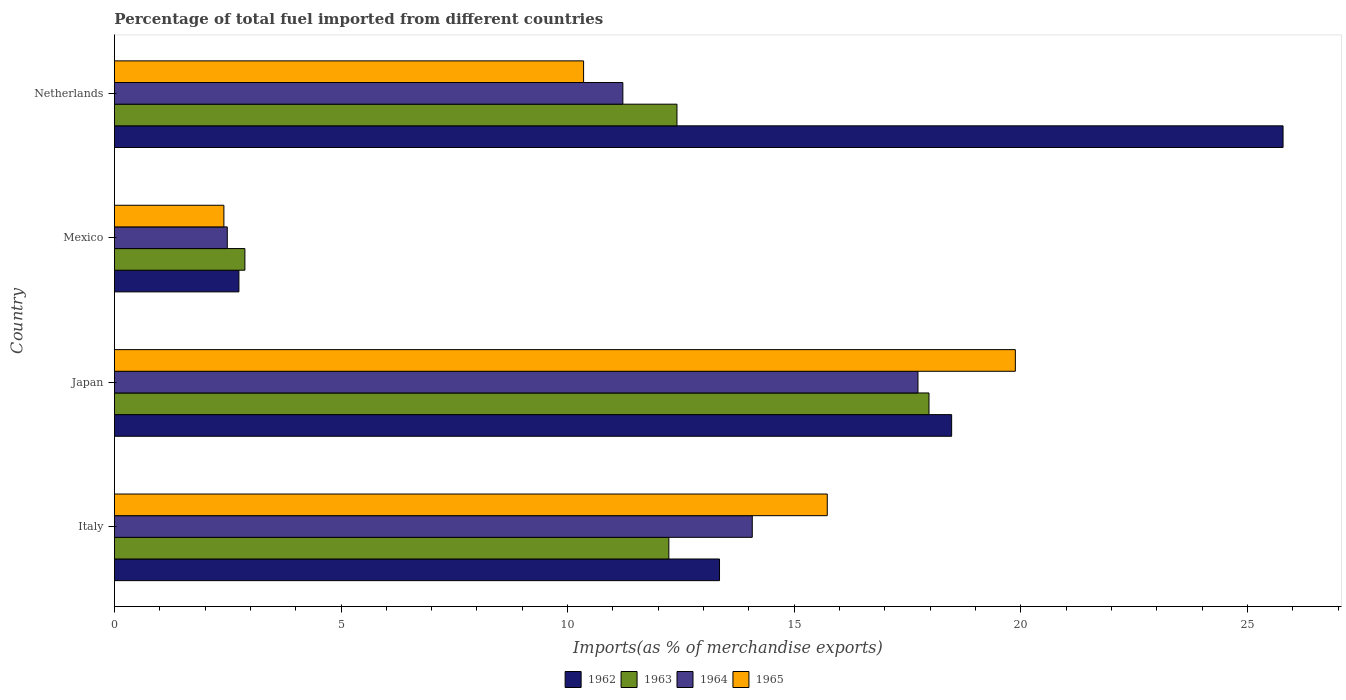How many different coloured bars are there?
Offer a terse response. 4. Are the number of bars on each tick of the Y-axis equal?
Offer a very short reply. Yes. What is the percentage of imports to different countries in 1964 in Japan?
Ensure brevity in your answer.  17.73. Across all countries, what is the maximum percentage of imports to different countries in 1962?
Offer a terse response. 25.79. Across all countries, what is the minimum percentage of imports to different countries in 1964?
Your answer should be very brief. 2.49. What is the total percentage of imports to different countries in 1964 in the graph?
Make the answer very short. 45.52. What is the difference between the percentage of imports to different countries in 1963 in Italy and that in Japan?
Your response must be concise. -5.74. What is the difference between the percentage of imports to different countries in 1964 in Mexico and the percentage of imports to different countries in 1963 in Netherlands?
Give a very brief answer. -9.92. What is the average percentage of imports to different countries in 1962 per country?
Your answer should be compact. 15.09. What is the difference between the percentage of imports to different countries in 1963 and percentage of imports to different countries in 1964 in Italy?
Offer a terse response. -1.84. What is the ratio of the percentage of imports to different countries in 1963 in Italy to that in Japan?
Give a very brief answer. 0.68. What is the difference between the highest and the second highest percentage of imports to different countries in 1963?
Give a very brief answer. 5.56. What is the difference between the highest and the lowest percentage of imports to different countries in 1962?
Make the answer very short. 23.04. Is the sum of the percentage of imports to different countries in 1962 in Japan and Mexico greater than the maximum percentage of imports to different countries in 1965 across all countries?
Ensure brevity in your answer.  Yes. Is it the case that in every country, the sum of the percentage of imports to different countries in 1963 and percentage of imports to different countries in 1964 is greater than the sum of percentage of imports to different countries in 1965 and percentage of imports to different countries in 1962?
Your answer should be compact. No. What does the 3rd bar from the top in Netherlands represents?
Your answer should be compact. 1963. What does the 4th bar from the bottom in Japan represents?
Keep it short and to the point. 1965. How many bars are there?
Keep it short and to the point. 16. Are all the bars in the graph horizontal?
Ensure brevity in your answer.  Yes. How many countries are there in the graph?
Offer a terse response. 4. Are the values on the major ticks of X-axis written in scientific E-notation?
Keep it short and to the point. No. What is the title of the graph?
Offer a terse response. Percentage of total fuel imported from different countries. Does "1967" appear as one of the legend labels in the graph?
Offer a terse response. No. What is the label or title of the X-axis?
Provide a succinct answer. Imports(as % of merchandise exports). What is the label or title of the Y-axis?
Give a very brief answer. Country. What is the Imports(as % of merchandise exports) in 1962 in Italy?
Provide a short and direct response. 13.35. What is the Imports(as % of merchandise exports) of 1963 in Italy?
Your answer should be very brief. 12.23. What is the Imports(as % of merchandise exports) of 1964 in Italy?
Make the answer very short. 14.07. What is the Imports(as % of merchandise exports) of 1965 in Italy?
Give a very brief answer. 15.73. What is the Imports(as % of merchandise exports) of 1962 in Japan?
Your response must be concise. 18.47. What is the Imports(as % of merchandise exports) in 1963 in Japan?
Keep it short and to the point. 17.97. What is the Imports(as % of merchandise exports) in 1964 in Japan?
Provide a short and direct response. 17.73. What is the Imports(as % of merchandise exports) in 1965 in Japan?
Ensure brevity in your answer.  19.88. What is the Imports(as % of merchandise exports) of 1962 in Mexico?
Provide a succinct answer. 2.75. What is the Imports(as % of merchandise exports) in 1963 in Mexico?
Your response must be concise. 2.88. What is the Imports(as % of merchandise exports) in 1964 in Mexico?
Your answer should be compact. 2.49. What is the Imports(as % of merchandise exports) of 1965 in Mexico?
Make the answer very short. 2.42. What is the Imports(as % of merchandise exports) in 1962 in Netherlands?
Ensure brevity in your answer.  25.79. What is the Imports(as % of merchandise exports) of 1963 in Netherlands?
Provide a succinct answer. 12.41. What is the Imports(as % of merchandise exports) of 1964 in Netherlands?
Keep it short and to the point. 11.22. What is the Imports(as % of merchandise exports) of 1965 in Netherlands?
Your answer should be very brief. 10.35. Across all countries, what is the maximum Imports(as % of merchandise exports) in 1962?
Offer a terse response. 25.79. Across all countries, what is the maximum Imports(as % of merchandise exports) in 1963?
Offer a very short reply. 17.97. Across all countries, what is the maximum Imports(as % of merchandise exports) of 1964?
Make the answer very short. 17.73. Across all countries, what is the maximum Imports(as % of merchandise exports) in 1965?
Your answer should be very brief. 19.88. Across all countries, what is the minimum Imports(as % of merchandise exports) of 1962?
Offer a very short reply. 2.75. Across all countries, what is the minimum Imports(as % of merchandise exports) of 1963?
Keep it short and to the point. 2.88. Across all countries, what is the minimum Imports(as % of merchandise exports) of 1964?
Provide a short and direct response. 2.49. Across all countries, what is the minimum Imports(as % of merchandise exports) in 1965?
Your answer should be very brief. 2.42. What is the total Imports(as % of merchandise exports) in 1962 in the graph?
Give a very brief answer. 60.36. What is the total Imports(as % of merchandise exports) of 1963 in the graph?
Offer a terse response. 45.5. What is the total Imports(as % of merchandise exports) in 1964 in the graph?
Provide a short and direct response. 45.52. What is the total Imports(as % of merchandise exports) of 1965 in the graph?
Your answer should be very brief. 48.38. What is the difference between the Imports(as % of merchandise exports) of 1962 in Italy and that in Japan?
Make the answer very short. -5.12. What is the difference between the Imports(as % of merchandise exports) in 1963 in Italy and that in Japan?
Your answer should be very brief. -5.74. What is the difference between the Imports(as % of merchandise exports) in 1964 in Italy and that in Japan?
Make the answer very short. -3.66. What is the difference between the Imports(as % of merchandise exports) of 1965 in Italy and that in Japan?
Ensure brevity in your answer.  -4.15. What is the difference between the Imports(as % of merchandise exports) in 1962 in Italy and that in Mexico?
Your response must be concise. 10.61. What is the difference between the Imports(as % of merchandise exports) in 1963 in Italy and that in Mexico?
Make the answer very short. 9.36. What is the difference between the Imports(as % of merchandise exports) in 1964 in Italy and that in Mexico?
Make the answer very short. 11.58. What is the difference between the Imports(as % of merchandise exports) in 1965 in Italy and that in Mexico?
Make the answer very short. 13.31. What is the difference between the Imports(as % of merchandise exports) of 1962 in Italy and that in Netherlands?
Offer a terse response. -12.44. What is the difference between the Imports(as % of merchandise exports) in 1963 in Italy and that in Netherlands?
Offer a very short reply. -0.18. What is the difference between the Imports(as % of merchandise exports) in 1964 in Italy and that in Netherlands?
Make the answer very short. 2.86. What is the difference between the Imports(as % of merchandise exports) in 1965 in Italy and that in Netherlands?
Your answer should be very brief. 5.38. What is the difference between the Imports(as % of merchandise exports) of 1962 in Japan and that in Mexico?
Ensure brevity in your answer.  15.73. What is the difference between the Imports(as % of merchandise exports) of 1963 in Japan and that in Mexico?
Provide a succinct answer. 15.1. What is the difference between the Imports(as % of merchandise exports) in 1964 in Japan and that in Mexico?
Ensure brevity in your answer.  15.24. What is the difference between the Imports(as % of merchandise exports) in 1965 in Japan and that in Mexico?
Ensure brevity in your answer.  17.46. What is the difference between the Imports(as % of merchandise exports) of 1962 in Japan and that in Netherlands?
Provide a short and direct response. -7.31. What is the difference between the Imports(as % of merchandise exports) of 1963 in Japan and that in Netherlands?
Provide a succinct answer. 5.56. What is the difference between the Imports(as % of merchandise exports) of 1964 in Japan and that in Netherlands?
Provide a succinct answer. 6.51. What is the difference between the Imports(as % of merchandise exports) in 1965 in Japan and that in Netherlands?
Offer a very short reply. 9.53. What is the difference between the Imports(as % of merchandise exports) of 1962 in Mexico and that in Netherlands?
Your response must be concise. -23.04. What is the difference between the Imports(as % of merchandise exports) in 1963 in Mexico and that in Netherlands?
Provide a short and direct response. -9.53. What is the difference between the Imports(as % of merchandise exports) in 1964 in Mexico and that in Netherlands?
Make the answer very short. -8.73. What is the difference between the Imports(as % of merchandise exports) of 1965 in Mexico and that in Netherlands?
Provide a succinct answer. -7.94. What is the difference between the Imports(as % of merchandise exports) in 1962 in Italy and the Imports(as % of merchandise exports) in 1963 in Japan?
Your response must be concise. -4.62. What is the difference between the Imports(as % of merchandise exports) in 1962 in Italy and the Imports(as % of merchandise exports) in 1964 in Japan?
Keep it short and to the point. -4.38. What is the difference between the Imports(as % of merchandise exports) in 1962 in Italy and the Imports(as % of merchandise exports) in 1965 in Japan?
Provide a short and direct response. -6.53. What is the difference between the Imports(as % of merchandise exports) in 1963 in Italy and the Imports(as % of merchandise exports) in 1964 in Japan?
Offer a very short reply. -5.5. What is the difference between the Imports(as % of merchandise exports) of 1963 in Italy and the Imports(as % of merchandise exports) of 1965 in Japan?
Offer a terse response. -7.65. What is the difference between the Imports(as % of merchandise exports) of 1964 in Italy and the Imports(as % of merchandise exports) of 1965 in Japan?
Ensure brevity in your answer.  -5.8. What is the difference between the Imports(as % of merchandise exports) of 1962 in Italy and the Imports(as % of merchandise exports) of 1963 in Mexico?
Provide a succinct answer. 10.47. What is the difference between the Imports(as % of merchandise exports) in 1962 in Italy and the Imports(as % of merchandise exports) in 1964 in Mexico?
Provide a short and direct response. 10.86. What is the difference between the Imports(as % of merchandise exports) of 1962 in Italy and the Imports(as % of merchandise exports) of 1965 in Mexico?
Give a very brief answer. 10.94. What is the difference between the Imports(as % of merchandise exports) in 1963 in Italy and the Imports(as % of merchandise exports) in 1964 in Mexico?
Your answer should be very brief. 9.74. What is the difference between the Imports(as % of merchandise exports) of 1963 in Italy and the Imports(as % of merchandise exports) of 1965 in Mexico?
Your response must be concise. 9.82. What is the difference between the Imports(as % of merchandise exports) of 1964 in Italy and the Imports(as % of merchandise exports) of 1965 in Mexico?
Your response must be concise. 11.66. What is the difference between the Imports(as % of merchandise exports) of 1962 in Italy and the Imports(as % of merchandise exports) of 1963 in Netherlands?
Give a very brief answer. 0.94. What is the difference between the Imports(as % of merchandise exports) in 1962 in Italy and the Imports(as % of merchandise exports) in 1964 in Netherlands?
Make the answer very short. 2.13. What is the difference between the Imports(as % of merchandise exports) in 1962 in Italy and the Imports(as % of merchandise exports) in 1965 in Netherlands?
Ensure brevity in your answer.  3. What is the difference between the Imports(as % of merchandise exports) of 1963 in Italy and the Imports(as % of merchandise exports) of 1964 in Netherlands?
Offer a terse response. 1.01. What is the difference between the Imports(as % of merchandise exports) in 1963 in Italy and the Imports(as % of merchandise exports) in 1965 in Netherlands?
Offer a very short reply. 1.88. What is the difference between the Imports(as % of merchandise exports) of 1964 in Italy and the Imports(as % of merchandise exports) of 1965 in Netherlands?
Keep it short and to the point. 3.72. What is the difference between the Imports(as % of merchandise exports) in 1962 in Japan and the Imports(as % of merchandise exports) in 1963 in Mexico?
Ensure brevity in your answer.  15.6. What is the difference between the Imports(as % of merchandise exports) in 1962 in Japan and the Imports(as % of merchandise exports) in 1964 in Mexico?
Provide a short and direct response. 15.98. What is the difference between the Imports(as % of merchandise exports) in 1962 in Japan and the Imports(as % of merchandise exports) in 1965 in Mexico?
Give a very brief answer. 16.06. What is the difference between the Imports(as % of merchandise exports) in 1963 in Japan and the Imports(as % of merchandise exports) in 1964 in Mexico?
Give a very brief answer. 15.48. What is the difference between the Imports(as % of merchandise exports) in 1963 in Japan and the Imports(as % of merchandise exports) in 1965 in Mexico?
Give a very brief answer. 15.56. What is the difference between the Imports(as % of merchandise exports) in 1964 in Japan and the Imports(as % of merchandise exports) in 1965 in Mexico?
Your answer should be very brief. 15.32. What is the difference between the Imports(as % of merchandise exports) of 1962 in Japan and the Imports(as % of merchandise exports) of 1963 in Netherlands?
Provide a short and direct response. 6.06. What is the difference between the Imports(as % of merchandise exports) in 1962 in Japan and the Imports(as % of merchandise exports) in 1964 in Netherlands?
Give a very brief answer. 7.25. What is the difference between the Imports(as % of merchandise exports) of 1962 in Japan and the Imports(as % of merchandise exports) of 1965 in Netherlands?
Your response must be concise. 8.12. What is the difference between the Imports(as % of merchandise exports) of 1963 in Japan and the Imports(as % of merchandise exports) of 1964 in Netherlands?
Offer a very short reply. 6.76. What is the difference between the Imports(as % of merchandise exports) of 1963 in Japan and the Imports(as % of merchandise exports) of 1965 in Netherlands?
Keep it short and to the point. 7.62. What is the difference between the Imports(as % of merchandise exports) of 1964 in Japan and the Imports(as % of merchandise exports) of 1965 in Netherlands?
Provide a short and direct response. 7.38. What is the difference between the Imports(as % of merchandise exports) of 1962 in Mexico and the Imports(as % of merchandise exports) of 1963 in Netherlands?
Your answer should be very brief. -9.67. What is the difference between the Imports(as % of merchandise exports) of 1962 in Mexico and the Imports(as % of merchandise exports) of 1964 in Netherlands?
Keep it short and to the point. -8.47. What is the difference between the Imports(as % of merchandise exports) of 1962 in Mexico and the Imports(as % of merchandise exports) of 1965 in Netherlands?
Give a very brief answer. -7.61. What is the difference between the Imports(as % of merchandise exports) of 1963 in Mexico and the Imports(as % of merchandise exports) of 1964 in Netherlands?
Keep it short and to the point. -8.34. What is the difference between the Imports(as % of merchandise exports) of 1963 in Mexico and the Imports(as % of merchandise exports) of 1965 in Netherlands?
Your answer should be very brief. -7.47. What is the difference between the Imports(as % of merchandise exports) in 1964 in Mexico and the Imports(as % of merchandise exports) in 1965 in Netherlands?
Provide a succinct answer. -7.86. What is the average Imports(as % of merchandise exports) of 1962 per country?
Offer a very short reply. 15.09. What is the average Imports(as % of merchandise exports) in 1963 per country?
Keep it short and to the point. 11.38. What is the average Imports(as % of merchandise exports) in 1964 per country?
Provide a succinct answer. 11.38. What is the average Imports(as % of merchandise exports) of 1965 per country?
Your answer should be very brief. 12.09. What is the difference between the Imports(as % of merchandise exports) of 1962 and Imports(as % of merchandise exports) of 1963 in Italy?
Your answer should be compact. 1.12. What is the difference between the Imports(as % of merchandise exports) of 1962 and Imports(as % of merchandise exports) of 1964 in Italy?
Your answer should be compact. -0.72. What is the difference between the Imports(as % of merchandise exports) in 1962 and Imports(as % of merchandise exports) in 1965 in Italy?
Make the answer very short. -2.38. What is the difference between the Imports(as % of merchandise exports) of 1963 and Imports(as % of merchandise exports) of 1964 in Italy?
Your response must be concise. -1.84. What is the difference between the Imports(as % of merchandise exports) of 1963 and Imports(as % of merchandise exports) of 1965 in Italy?
Offer a terse response. -3.5. What is the difference between the Imports(as % of merchandise exports) of 1964 and Imports(as % of merchandise exports) of 1965 in Italy?
Your answer should be very brief. -1.65. What is the difference between the Imports(as % of merchandise exports) of 1962 and Imports(as % of merchandise exports) of 1963 in Japan?
Your answer should be compact. 0.5. What is the difference between the Imports(as % of merchandise exports) in 1962 and Imports(as % of merchandise exports) in 1964 in Japan?
Offer a very short reply. 0.74. What is the difference between the Imports(as % of merchandise exports) in 1962 and Imports(as % of merchandise exports) in 1965 in Japan?
Ensure brevity in your answer.  -1.41. What is the difference between the Imports(as % of merchandise exports) of 1963 and Imports(as % of merchandise exports) of 1964 in Japan?
Your response must be concise. 0.24. What is the difference between the Imports(as % of merchandise exports) in 1963 and Imports(as % of merchandise exports) in 1965 in Japan?
Offer a terse response. -1.91. What is the difference between the Imports(as % of merchandise exports) of 1964 and Imports(as % of merchandise exports) of 1965 in Japan?
Your answer should be very brief. -2.15. What is the difference between the Imports(as % of merchandise exports) in 1962 and Imports(as % of merchandise exports) in 1963 in Mexico?
Make the answer very short. -0.13. What is the difference between the Imports(as % of merchandise exports) in 1962 and Imports(as % of merchandise exports) in 1964 in Mexico?
Your response must be concise. 0.26. What is the difference between the Imports(as % of merchandise exports) of 1962 and Imports(as % of merchandise exports) of 1965 in Mexico?
Your answer should be very brief. 0.33. What is the difference between the Imports(as % of merchandise exports) of 1963 and Imports(as % of merchandise exports) of 1964 in Mexico?
Provide a succinct answer. 0.39. What is the difference between the Imports(as % of merchandise exports) of 1963 and Imports(as % of merchandise exports) of 1965 in Mexico?
Your response must be concise. 0.46. What is the difference between the Imports(as % of merchandise exports) of 1964 and Imports(as % of merchandise exports) of 1965 in Mexico?
Give a very brief answer. 0.07. What is the difference between the Imports(as % of merchandise exports) of 1962 and Imports(as % of merchandise exports) of 1963 in Netherlands?
Your answer should be very brief. 13.37. What is the difference between the Imports(as % of merchandise exports) of 1962 and Imports(as % of merchandise exports) of 1964 in Netherlands?
Offer a terse response. 14.57. What is the difference between the Imports(as % of merchandise exports) of 1962 and Imports(as % of merchandise exports) of 1965 in Netherlands?
Ensure brevity in your answer.  15.43. What is the difference between the Imports(as % of merchandise exports) in 1963 and Imports(as % of merchandise exports) in 1964 in Netherlands?
Provide a short and direct response. 1.19. What is the difference between the Imports(as % of merchandise exports) in 1963 and Imports(as % of merchandise exports) in 1965 in Netherlands?
Offer a very short reply. 2.06. What is the difference between the Imports(as % of merchandise exports) of 1964 and Imports(as % of merchandise exports) of 1965 in Netherlands?
Ensure brevity in your answer.  0.87. What is the ratio of the Imports(as % of merchandise exports) of 1962 in Italy to that in Japan?
Your answer should be compact. 0.72. What is the ratio of the Imports(as % of merchandise exports) in 1963 in Italy to that in Japan?
Make the answer very short. 0.68. What is the ratio of the Imports(as % of merchandise exports) of 1964 in Italy to that in Japan?
Make the answer very short. 0.79. What is the ratio of the Imports(as % of merchandise exports) of 1965 in Italy to that in Japan?
Provide a short and direct response. 0.79. What is the ratio of the Imports(as % of merchandise exports) in 1962 in Italy to that in Mexico?
Provide a succinct answer. 4.86. What is the ratio of the Imports(as % of merchandise exports) of 1963 in Italy to that in Mexico?
Your answer should be compact. 4.25. What is the ratio of the Imports(as % of merchandise exports) in 1964 in Italy to that in Mexico?
Make the answer very short. 5.65. What is the ratio of the Imports(as % of merchandise exports) in 1965 in Italy to that in Mexico?
Provide a succinct answer. 6.51. What is the ratio of the Imports(as % of merchandise exports) of 1962 in Italy to that in Netherlands?
Give a very brief answer. 0.52. What is the ratio of the Imports(as % of merchandise exports) of 1963 in Italy to that in Netherlands?
Your answer should be very brief. 0.99. What is the ratio of the Imports(as % of merchandise exports) of 1964 in Italy to that in Netherlands?
Offer a very short reply. 1.25. What is the ratio of the Imports(as % of merchandise exports) of 1965 in Italy to that in Netherlands?
Your response must be concise. 1.52. What is the ratio of the Imports(as % of merchandise exports) in 1962 in Japan to that in Mexico?
Keep it short and to the point. 6.72. What is the ratio of the Imports(as % of merchandise exports) of 1963 in Japan to that in Mexico?
Offer a terse response. 6.24. What is the ratio of the Imports(as % of merchandise exports) of 1964 in Japan to that in Mexico?
Your answer should be compact. 7.12. What is the ratio of the Imports(as % of merchandise exports) in 1965 in Japan to that in Mexico?
Provide a succinct answer. 8.23. What is the ratio of the Imports(as % of merchandise exports) in 1962 in Japan to that in Netherlands?
Provide a succinct answer. 0.72. What is the ratio of the Imports(as % of merchandise exports) of 1963 in Japan to that in Netherlands?
Provide a succinct answer. 1.45. What is the ratio of the Imports(as % of merchandise exports) in 1964 in Japan to that in Netherlands?
Keep it short and to the point. 1.58. What is the ratio of the Imports(as % of merchandise exports) in 1965 in Japan to that in Netherlands?
Make the answer very short. 1.92. What is the ratio of the Imports(as % of merchandise exports) of 1962 in Mexico to that in Netherlands?
Make the answer very short. 0.11. What is the ratio of the Imports(as % of merchandise exports) in 1963 in Mexico to that in Netherlands?
Make the answer very short. 0.23. What is the ratio of the Imports(as % of merchandise exports) in 1964 in Mexico to that in Netherlands?
Offer a terse response. 0.22. What is the ratio of the Imports(as % of merchandise exports) of 1965 in Mexico to that in Netherlands?
Your response must be concise. 0.23. What is the difference between the highest and the second highest Imports(as % of merchandise exports) in 1962?
Provide a short and direct response. 7.31. What is the difference between the highest and the second highest Imports(as % of merchandise exports) in 1963?
Give a very brief answer. 5.56. What is the difference between the highest and the second highest Imports(as % of merchandise exports) of 1964?
Offer a very short reply. 3.66. What is the difference between the highest and the second highest Imports(as % of merchandise exports) in 1965?
Provide a short and direct response. 4.15. What is the difference between the highest and the lowest Imports(as % of merchandise exports) of 1962?
Give a very brief answer. 23.04. What is the difference between the highest and the lowest Imports(as % of merchandise exports) in 1963?
Offer a very short reply. 15.1. What is the difference between the highest and the lowest Imports(as % of merchandise exports) in 1964?
Your answer should be compact. 15.24. What is the difference between the highest and the lowest Imports(as % of merchandise exports) of 1965?
Your answer should be very brief. 17.46. 